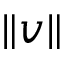Convert formula to latex. <formula><loc_0><loc_0><loc_500><loc_500>\| v \|</formula> 